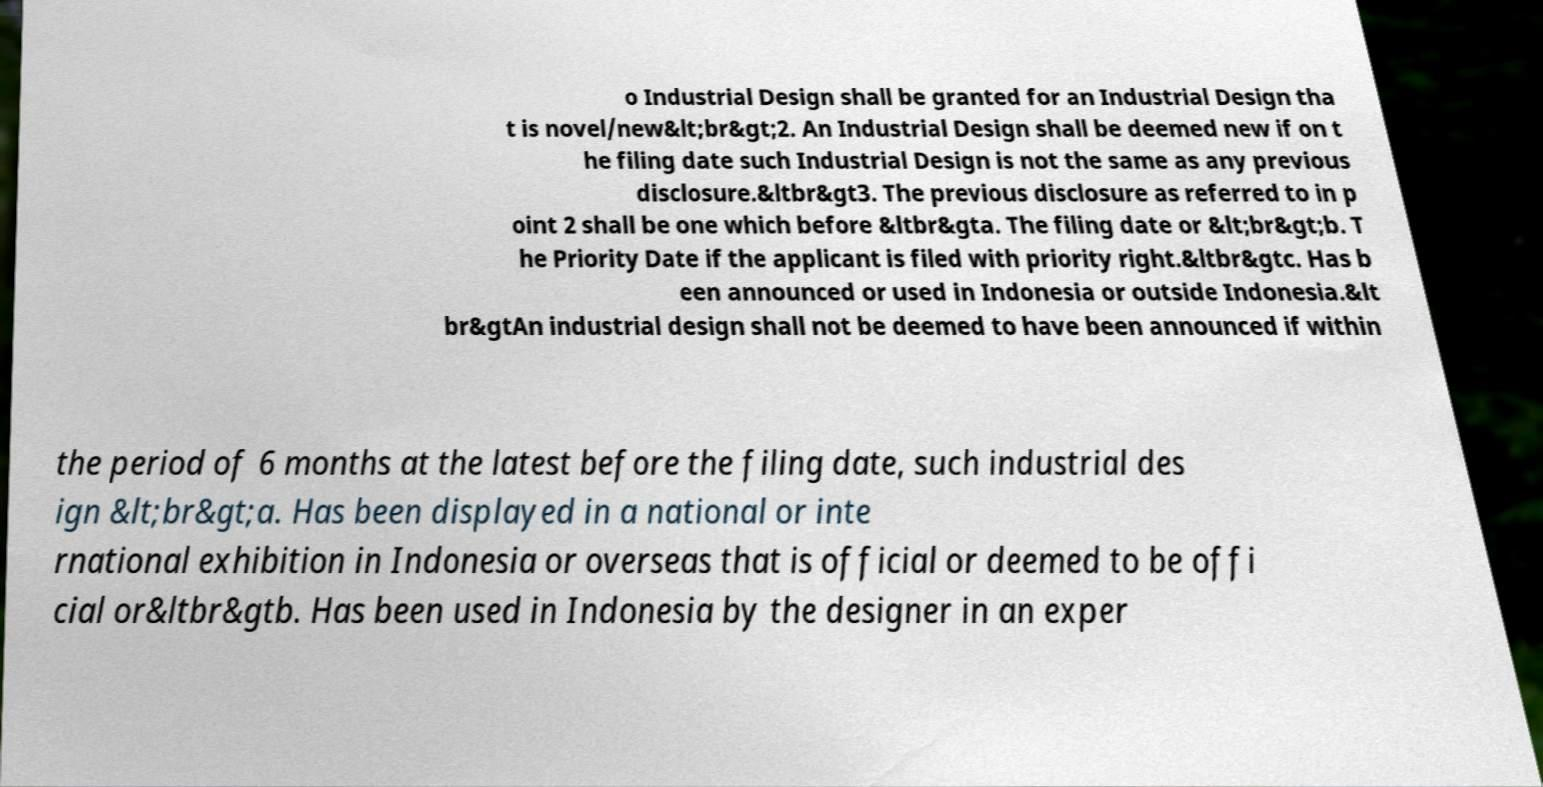Can you accurately transcribe the text from the provided image for me? o Industrial Design shall be granted for an Industrial Design tha t is novel/new&lt;br&gt;2. An Industrial Design shall be deemed new if on t he filing date such Industrial Design is not the same as any previous disclosure.&ltbr&gt3. The previous disclosure as referred to in p oint 2 shall be one which before &ltbr&gta. The filing date or &lt;br&gt;b. T he Priority Date if the applicant is filed with priority right.&ltbr&gtc. Has b een announced or used in Indonesia or outside Indonesia.&lt br&gtAn industrial design shall not be deemed to have been announced if within the period of 6 months at the latest before the filing date, such industrial des ign &lt;br&gt;a. Has been displayed in a national or inte rnational exhibition in Indonesia or overseas that is official or deemed to be offi cial or&ltbr&gtb. Has been used in Indonesia by the designer in an exper 